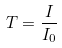<formula> <loc_0><loc_0><loc_500><loc_500>T = \frac { I } { I _ { 0 } }</formula> 